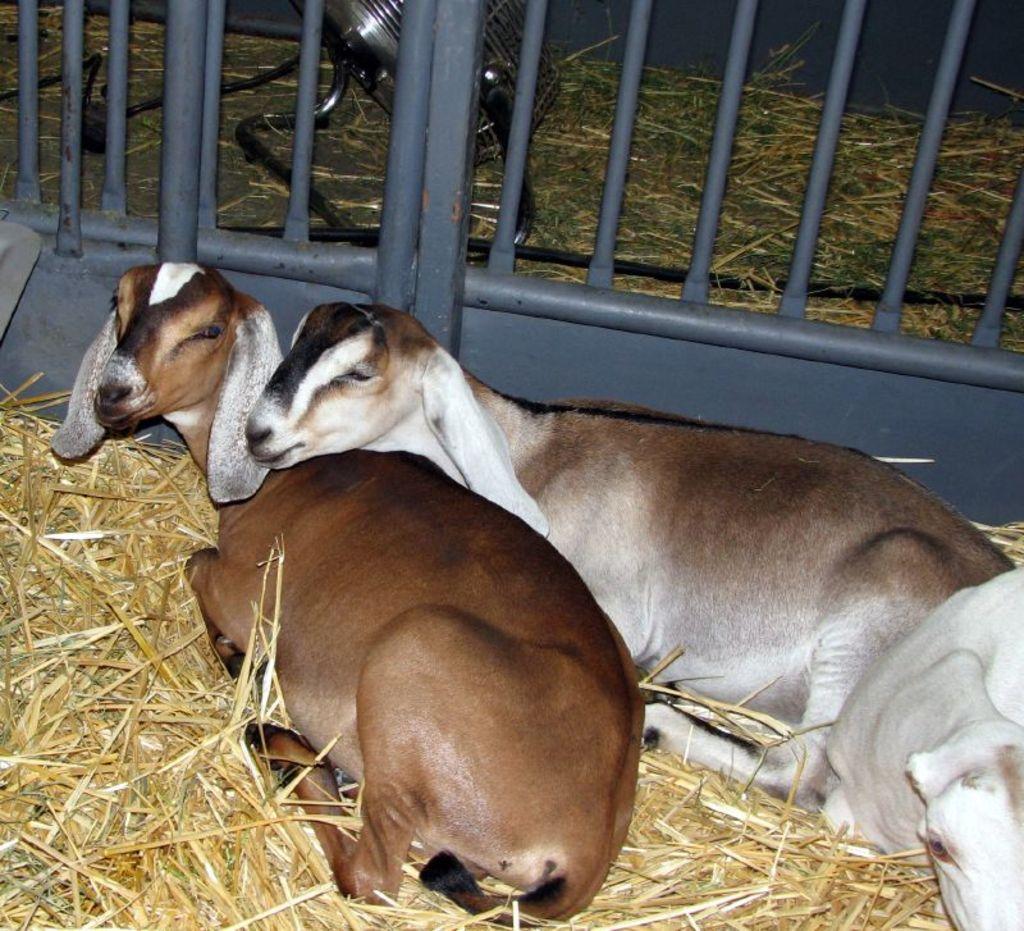Describe this image in one or two sentences. In this image I can see yellow grass, iron bars and here I can see few goats. I can see colour of these goats are white and brown. 